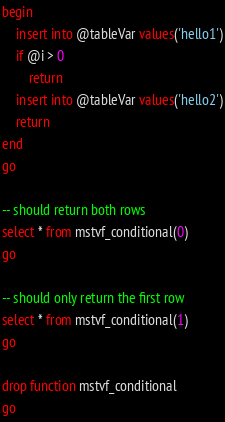<code> <loc_0><loc_0><loc_500><loc_500><_SQL_>begin
	insert into @tableVar values('hello1')
	if @i > 0
		return
	insert into @tableVar values('hello2')
	return
end
go

-- should return both rows
select * from mstvf_conditional(0)
go

-- should only return the first row
select * from mstvf_conditional(1)
go

drop function mstvf_conditional
go
</code> 